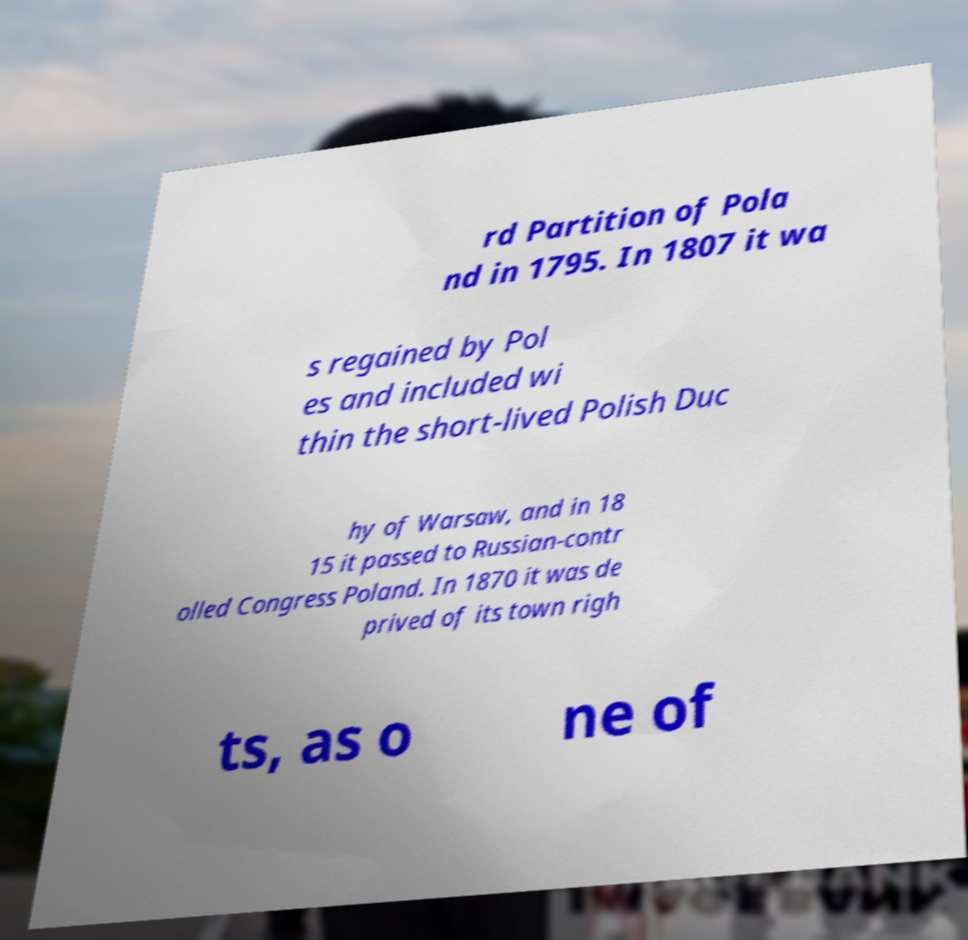Can you read and provide the text displayed in the image?This photo seems to have some interesting text. Can you extract and type it out for me? rd Partition of Pola nd in 1795. In 1807 it wa s regained by Pol es and included wi thin the short-lived Polish Duc hy of Warsaw, and in 18 15 it passed to Russian-contr olled Congress Poland. In 1870 it was de prived of its town righ ts, as o ne of 